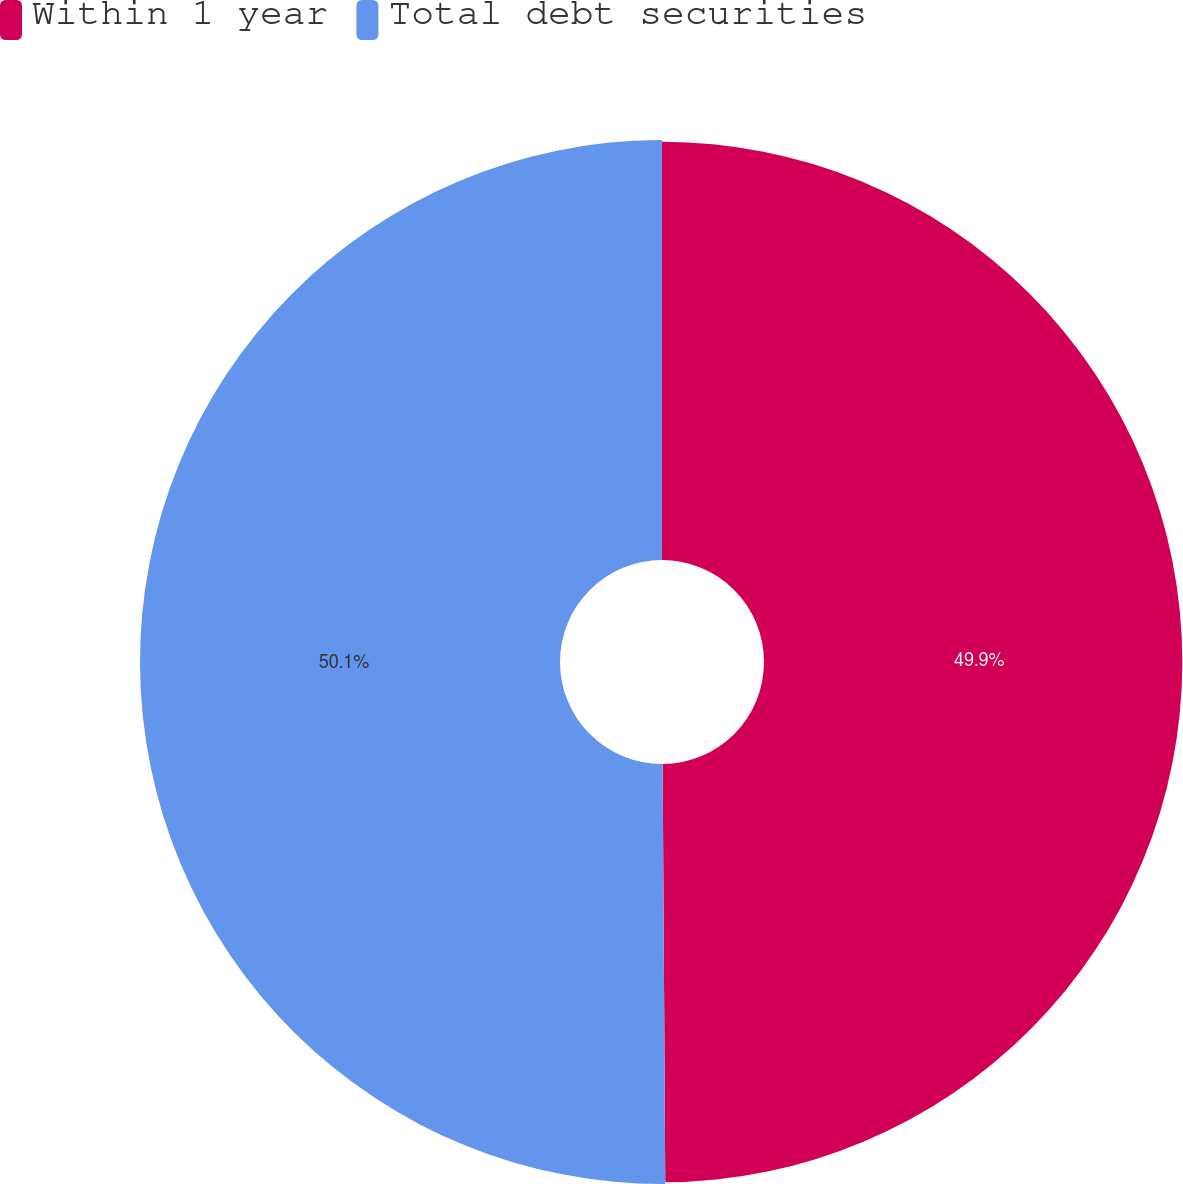<chart> <loc_0><loc_0><loc_500><loc_500><pie_chart><fcel>Within 1 year<fcel>Total debt securities<nl><fcel>49.9%<fcel>50.1%<nl></chart> 